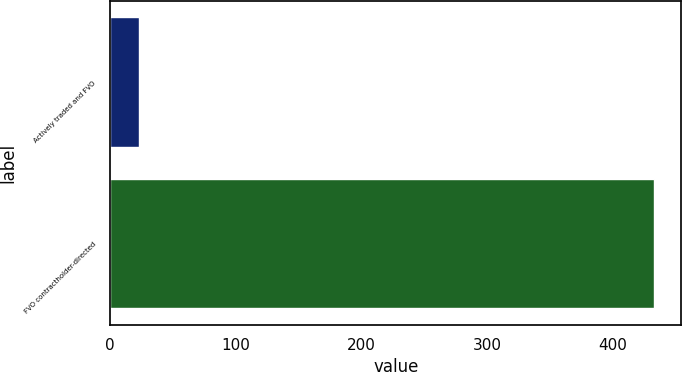<chart> <loc_0><loc_0><loc_500><loc_500><bar_chart><fcel>Actively traded and FVO<fcel>FVO contractholder-directed<nl><fcel>23<fcel>433<nl></chart> 